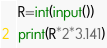Convert code to text. <code><loc_0><loc_0><loc_500><loc_500><_Python_>R=int(input())
print(R*2*3.141)</code> 